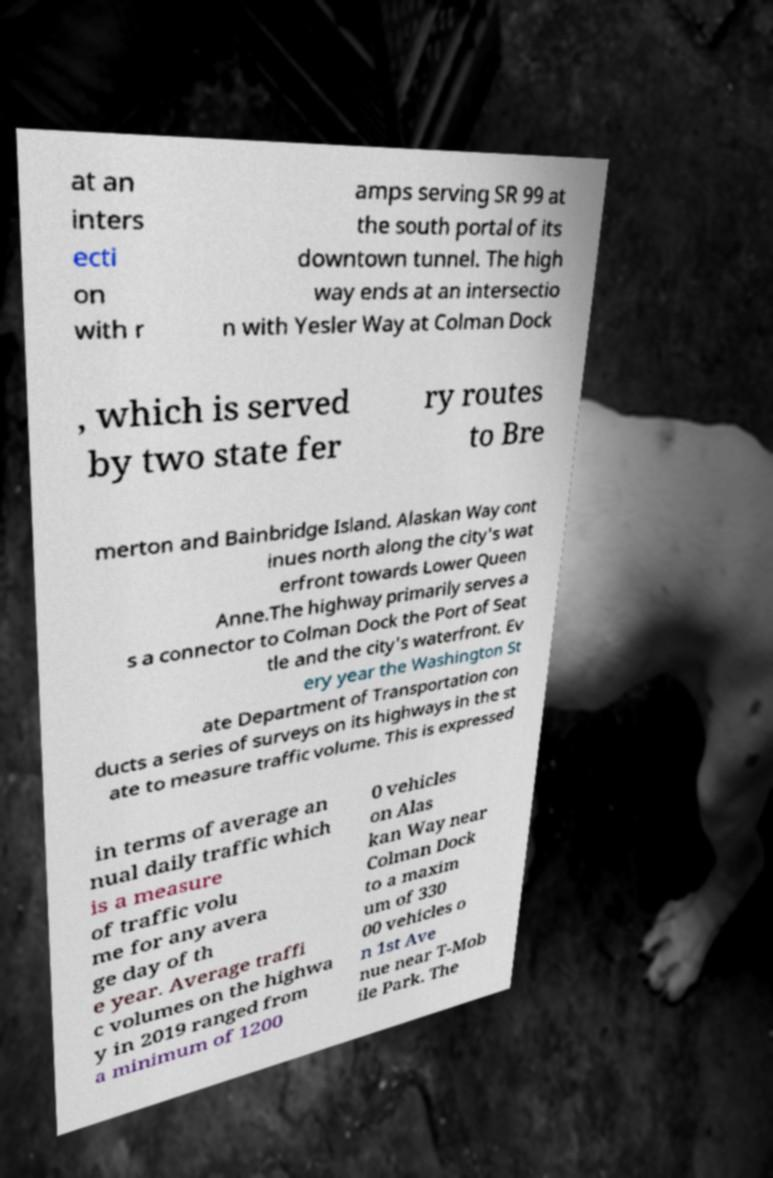For documentation purposes, I need the text within this image transcribed. Could you provide that? at an inters ecti on with r amps serving SR 99 at the south portal of its downtown tunnel. The high way ends at an intersectio n with Yesler Way at Colman Dock , which is served by two state fer ry routes to Bre merton and Bainbridge Island. Alaskan Way cont inues north along the city's wat erfront towards Lower Queen Anne.The highway primarily serves a s a connector to Colman Dock the Port of Seat tle and the city's waterfront. Ev ery year the Washington St ate Department of Transportation con ducts a series of surveys on its highways in the st ate to measure traffic volume. This is expressed in terms of average an nual daily traffic which is a measure of traffic volu me for any avera ge day of th e year. Average traffi c volumes on the highwa y in 2019 ranged from a minimum of 1200 0 vehicles on Alas kan Way near Colman Dock to a maxim um of 330 00 vehicles o n 1st Ave nue near T-Mob ile Park. The 